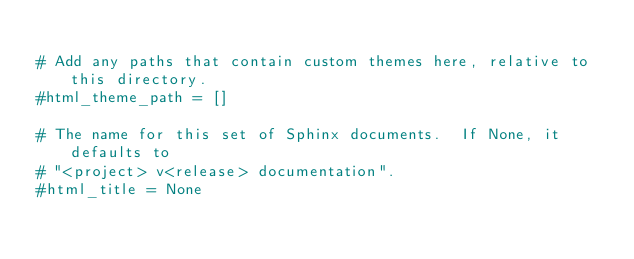Convert code to text. <code><loc_0><loc_0><loc_500><loc_500><_Python_>
# Add any paths that contain custom themes here, relative to this directory.
#html_theme_path = []

# The name for this set of Sphinx documents.  If None, it defaults to
# "<project> v<release> documentation".
#html_title = None
</code> 